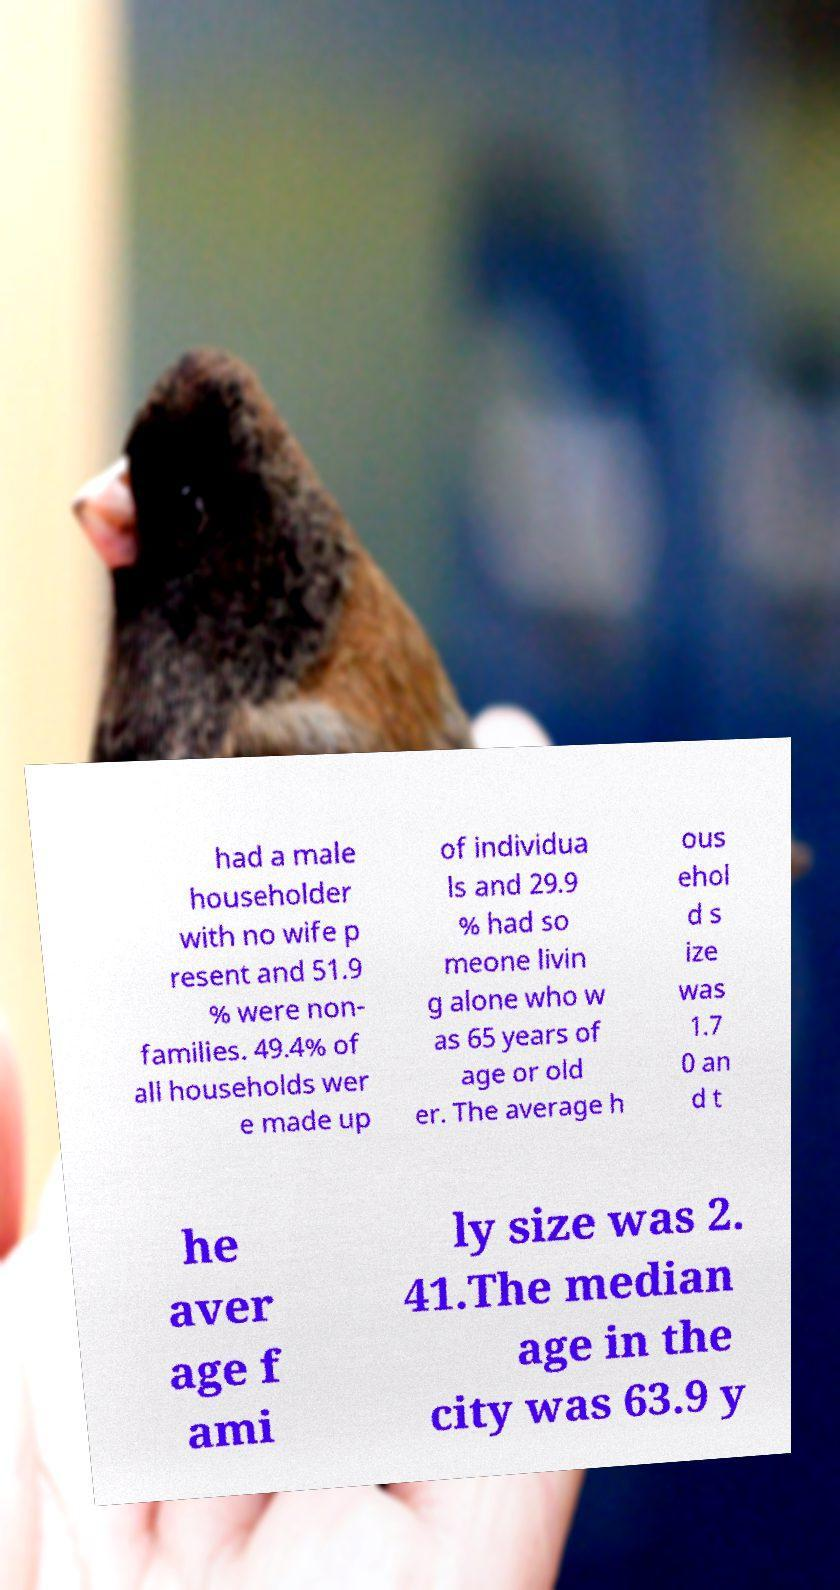Can you read and provide the text displayed in the image?This photo seems to have some interesting text. Can you extract and type it out for me? had a male householder with no wife p resent and 51.9 % were non- families. 49.4% of all households wer e made up of individua ls and 29.9 % had so meone livin g alone who w as 65 years of age or old er. The average h ous ehol d s ize was 1.7 0 an d t he aver age f ami ly size was 2. 41.The median age in the city was 63.9 y 